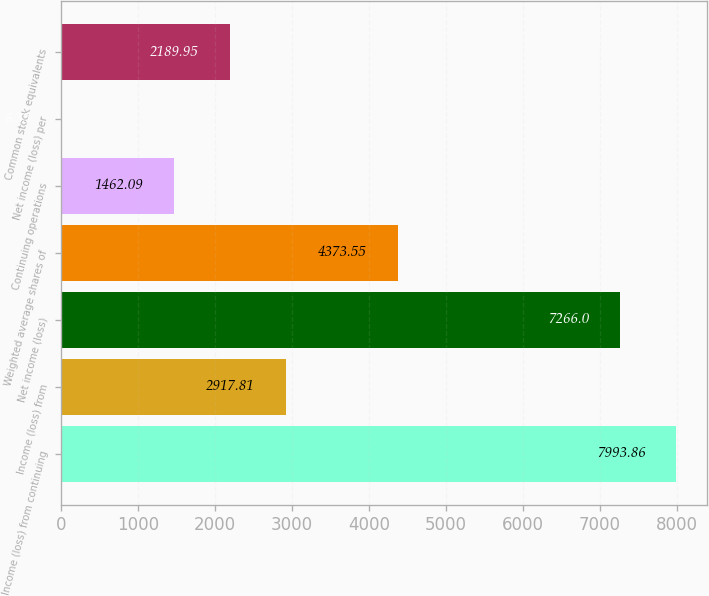<chart> <loc_0><loc_0><loc_500><loc_500><bar_chart><fcel>Income (loss) from continuing<fcel>Income (loss) from<fcel>Net income (loss)<fcel>Weighted average shares of<fcel>Continuing operations<fcel>Net income (loss) per<fcel>Common stock equivalents<nl><fcel>7993.86<fcel>2917.81<fcel>7266<fcel>4373.55<fcel>1462.09<fcel>6.35<fcel>2189.95<nl></chart> 